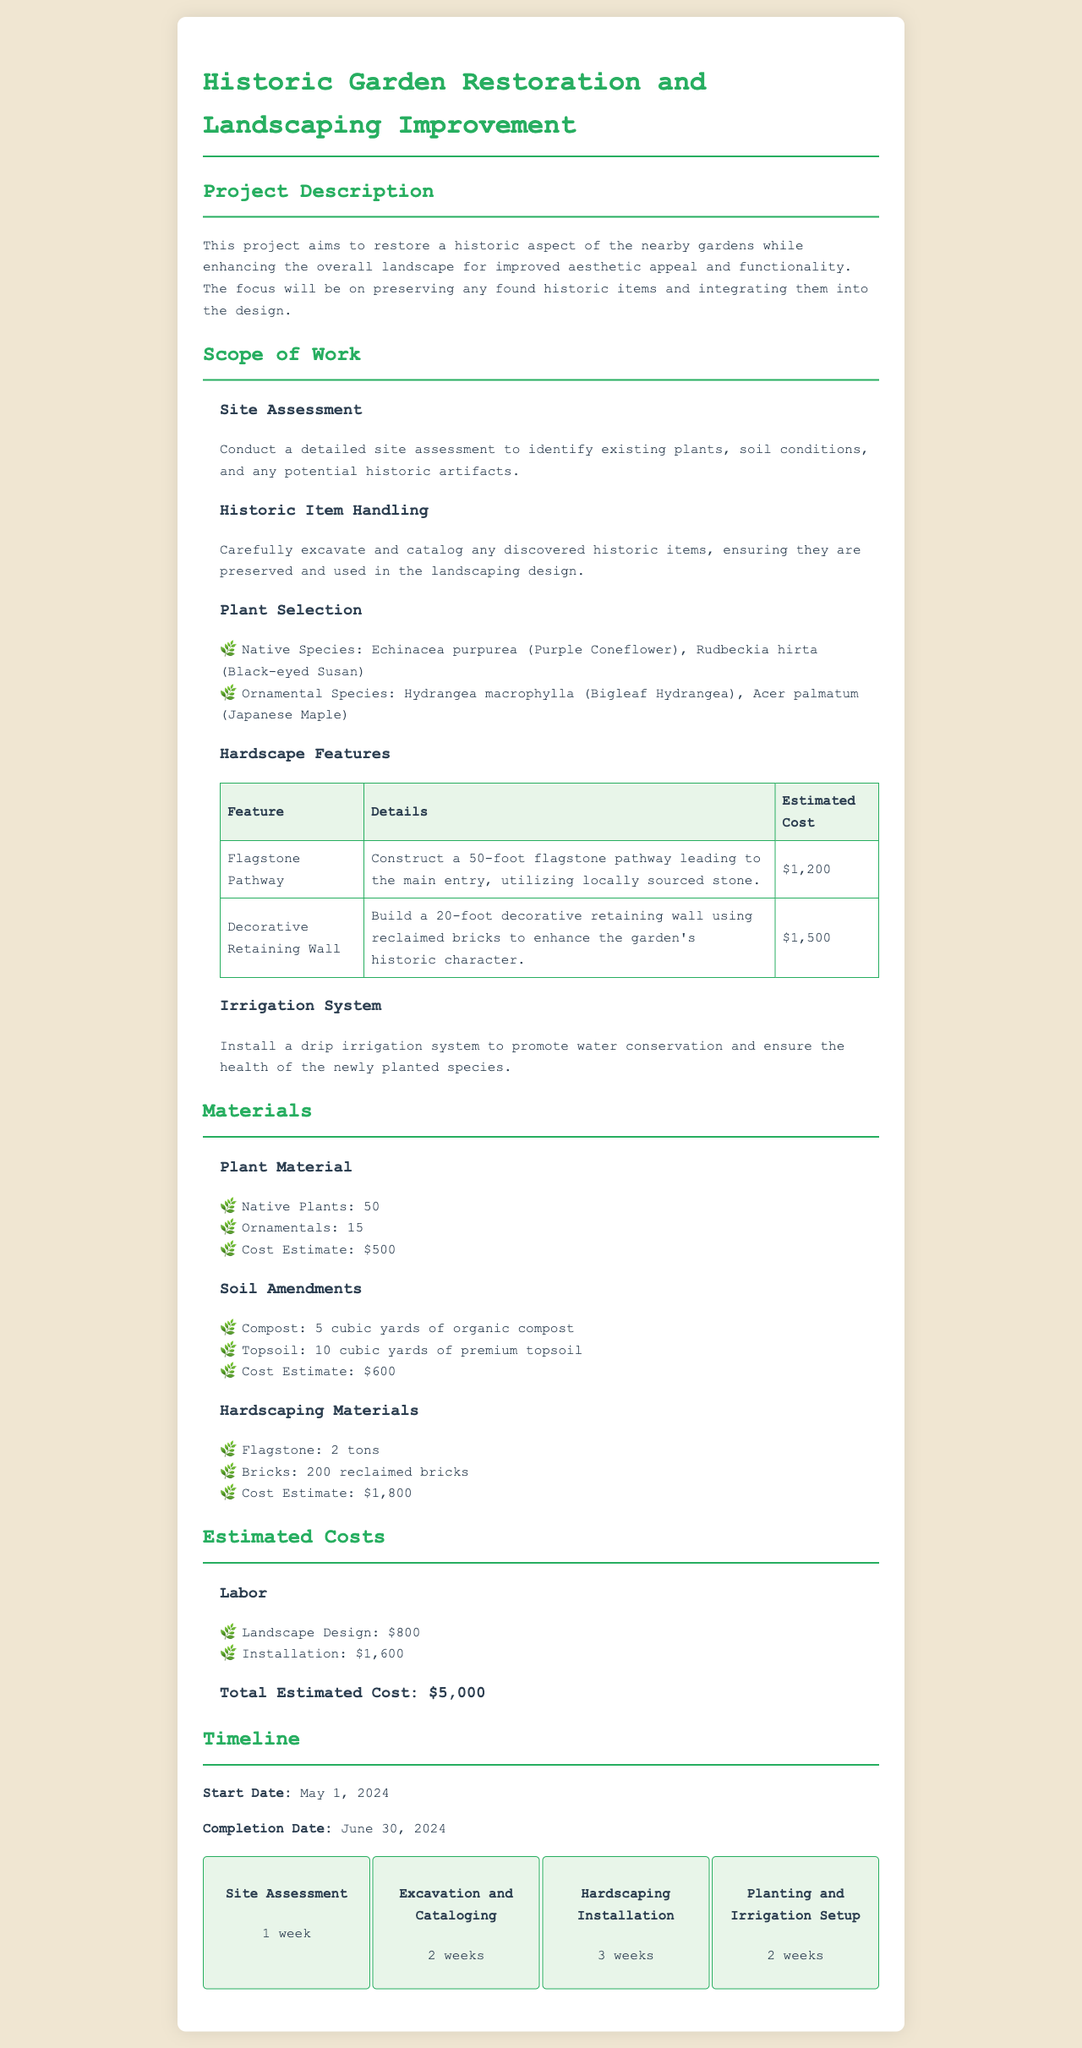what is the title of the project proposal? The title is stated at the top of the document and is "Historic Garden Restoration and Landscaping Improvement."
Answer: Historic Garden Restoration and Landscaping Improvement when is the start date of the project? The start date is mentioned in the timeline section of the document.
Answer: May 1, 2024 how many native plants are included in the project? The number of native plants is specified under the "Plant Material" section.
Answer: 50 what is the estimated cost of the decorative retaining wall? The estimated cost is provided in the "Hardscape Features" table.
Answer: $1,500 how long will the site assessment phase take? The duration is mentioned in the timeline section.
Answer: 1 week what type of irrigation system will be installed? The type of irrigation system is mentioned under the "Irrigation System" subsection.
Answer: drip irrigation system how much compost is needed for the project? The amount of compost is specified in the "Soil Amendments" section.
Answer: 5 cubic yards what is the total estimated cost of the project? The total estimated cost is summarized in the "Estimated Costs" section.
Answer: $5,000 how many ornamental species are selected for the project? The number of ornamental species is listed under the "Plant Selection."
Answer: 15 